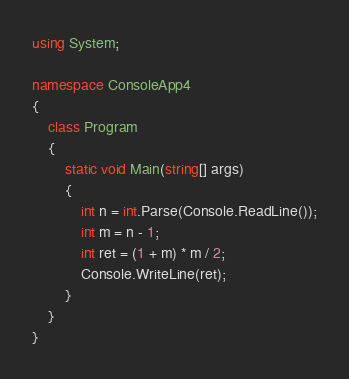Convert code to text. <code><loc_0><loc_0><loc_500><loc_500><_C#_>using System;

namespace ConsoleApp4
{
	class Program
	{
		static void Main(string[] args)
		{
			int n = int.Parse(Console.ReadLine());
			int m = n - 1;
			int ret = (1 + m) * m / 2;
			Console.WriteLine(ret);
		}
	}
}
</code> 